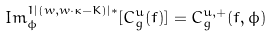<formula> <loc_0><loc_0><loc_500><loc_500>I m ^ { 1 | ( w , w \cdot \kappa - K ) | * } _ { \phi } [ C ^ { u } _ { g } ( f ) ] = C ^ { u , + } _ { g } ( f , \phi )</formula> 